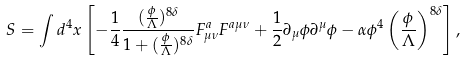Convert formula to latex. <formula><loc_0><loc_0><loc_500><loc_500>S = \int d ^ { 4 } x \left [ - \frac { 1 } { 4 } \frac { ( \frac { \phi } { \Lambda } ) ^ { 8 \delta } } { 1 + ( \frac { \phi } { \Lambda } ) ^ { 8 \delta } } F ^ { a } _ { \mu \nu } F ^ { a \mu \nu } + \frac { 1 } { 2 } \partial _ { \mu } \phi \partial ^ { \mu } \phi - \alpha \phi ^ { 4 } \left ( \frac { \phi } { \Lambda } \right ) ^ { 8 \delta } \right ] ,</formula> 